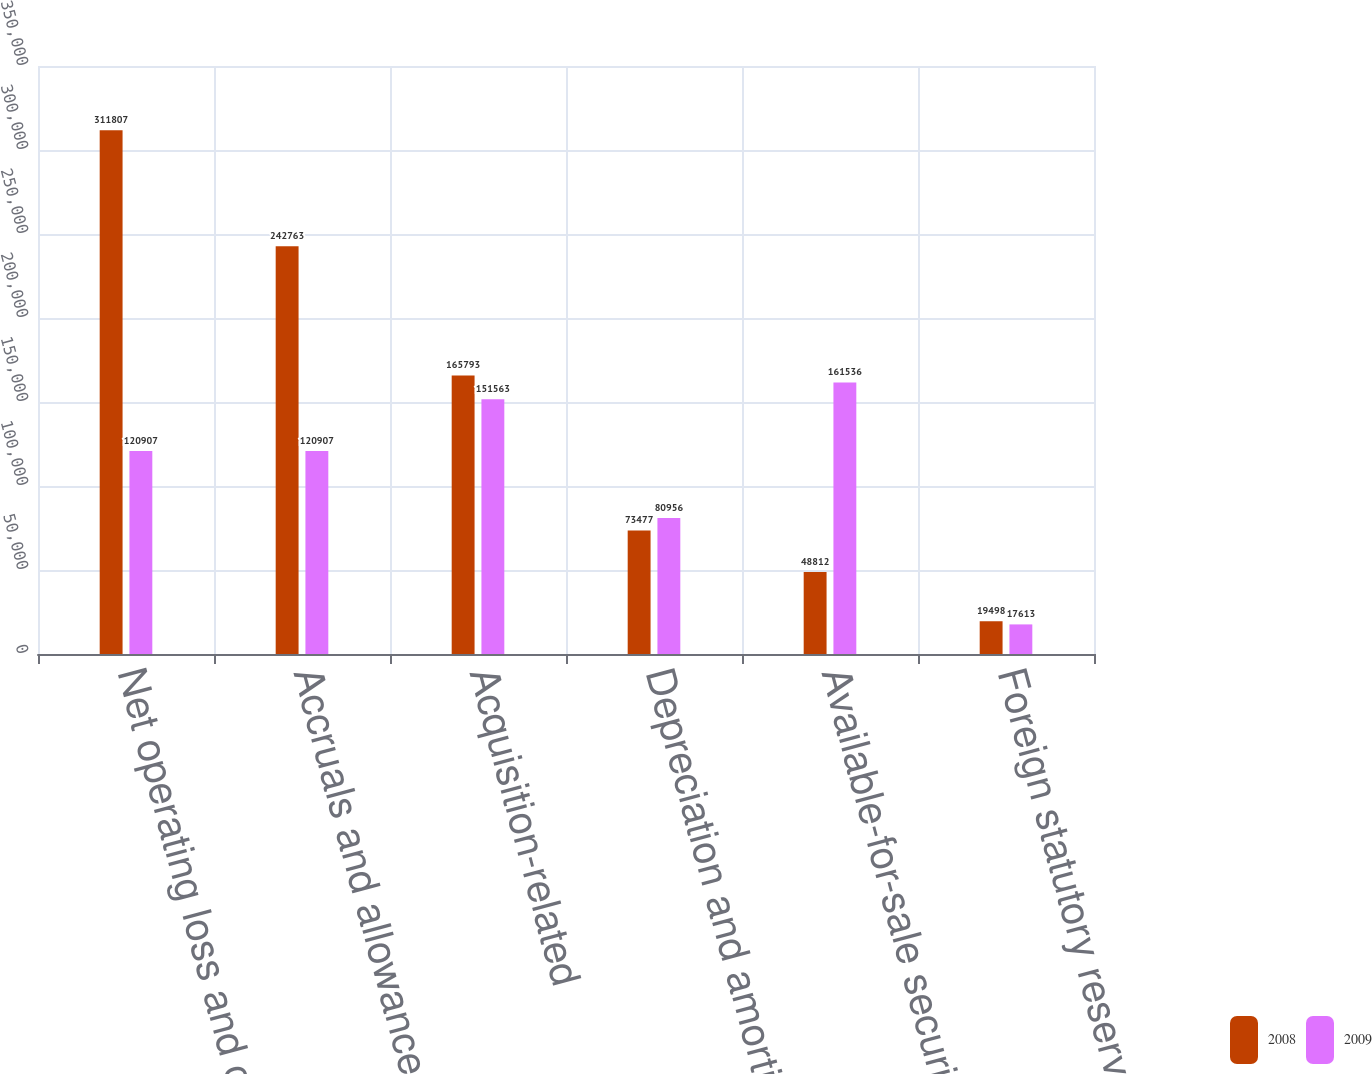Convert chart to OTSL. <chart><loc_0><loc_0><loc_500><loc_500><stacked_bar_chart><ecel><fcel>Net operating loss and credits<fcel>Accruals and allowances<fcel>Acquisition-related<fcel>Depreciation and amortization<fcel>Available-for-sale securities<fcel>Foreign statutory reserves<nl><fcel>2008<fcel>311807<fcel>242763<fcel>165793<fcel>73477<fcel>48812<fcel>19498<nl><fcel>2009<fcel>120907<fcel>120907<fcel>151563<fcel>80956<fcel>161536<fcel>17613<nl></chart> 